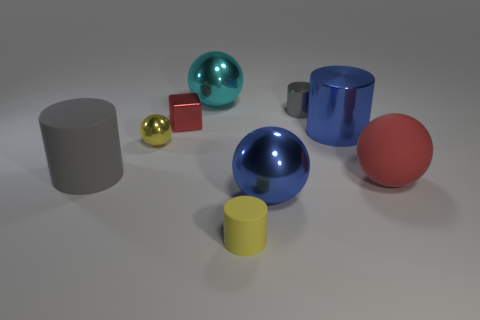There is a block that is the same color as the large rubber sphere; what material is it?
Provide a short and direct response. Metal. How many other things are there of the same color as the tiny metallic cube?
Give a very brief answer. 1. There is a metallic block; does it have the same color as the big rubber thing that is to the right of the small matte thing?
Give a very brief answer. Yes. How many tiny cylinders are in front of the yellow object that is behind the yellow rubber cylinder?
Keep it short and to the point. 1. What material is the big red ball that is to the right of the small cylinder behind the big cylinder to the left of the cyan shiny sphere made of?
Your response must be concise. Rubber. What material is the thing that is behind the tiny yellow rubber cylinder and in front of the red rubber object?
Provide a succinct answer. Metal. How many other things have the same shape as the red matte object?
Give a very brief answer. 3. There is a yellow thing that is in front of the yellow shiny ball to the left of the red shiny block; what size is it?
Your response must be concise. Small. There is a tiny cylinder that is to the right of the tiny yellow rubber cylinder; is its color the same as the big cylinder that is to the left of the tiny gray metallic cylinder?
Your response must be concise. Yes. What number of objects are right of the metal object behind the cylinder that is behind the tiny red cube?
Your response must be concise. 5. 